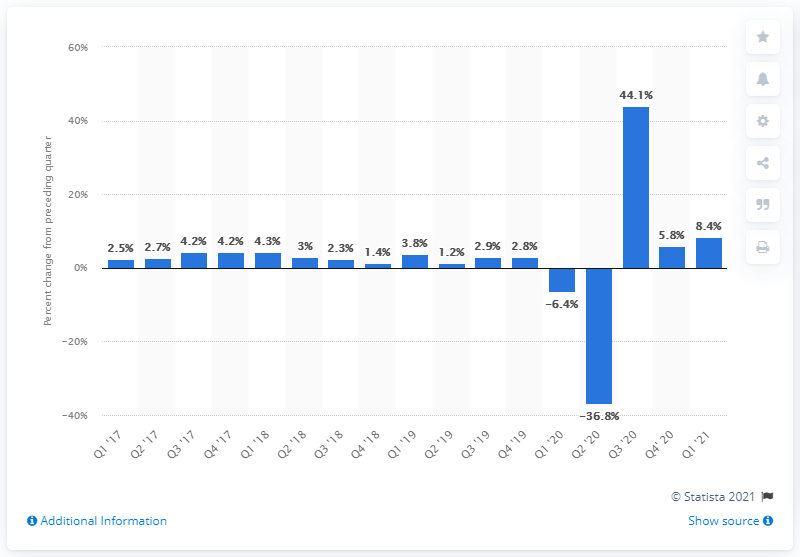Indicate a few pertinent items in this graphic. In the first quarter of 2021, the nonfarm business sector output in the US increased by 8.4%. 